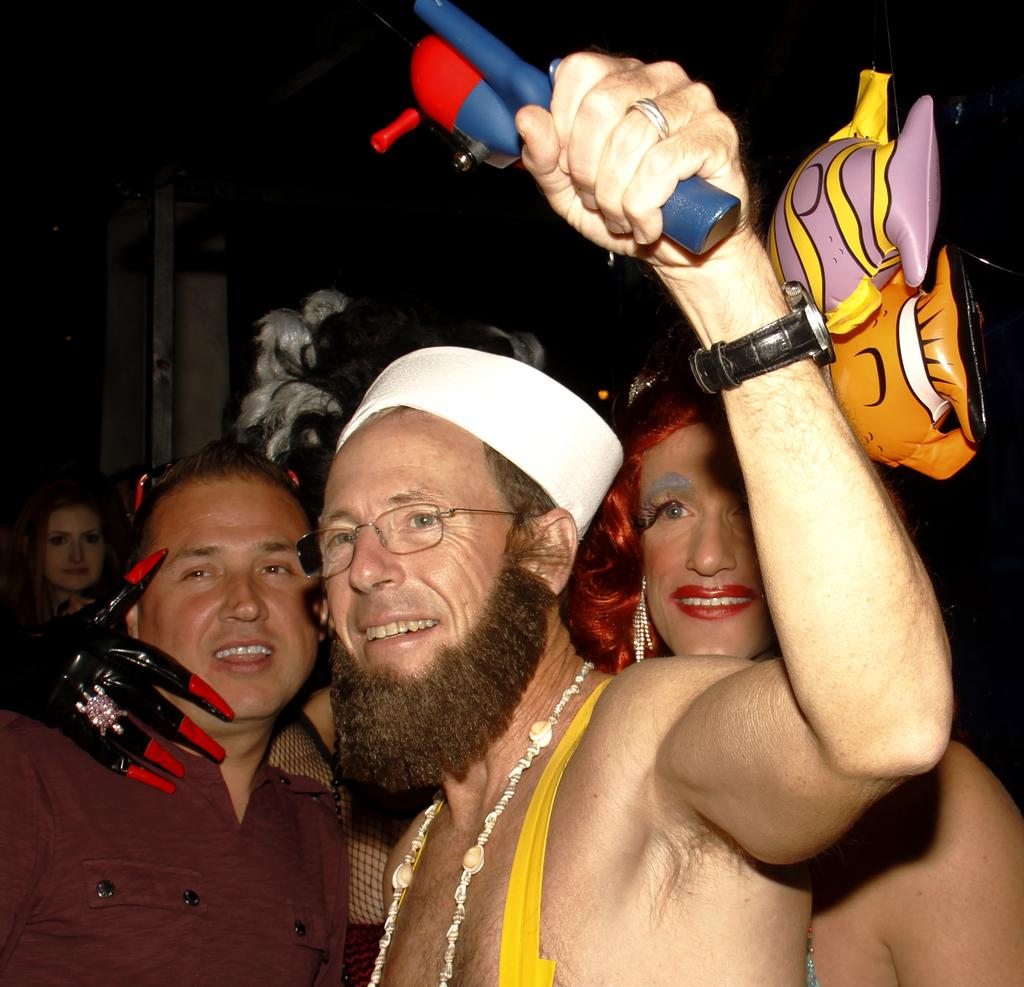What are the people in the image doing? The people in the image are standing in the center. Can you describe the appearance of some of the people? Some of the people are wearing costumes. What else is present in the image besides the people? There is an air balloon in the image. What can be seen in the background of the image? There is a wall in the background of the image. How many eyes can be seen in the jar in the image? There is no jar or eyes present in the image. What type of men are depicted in the image? The provided facts do not mention any specific type of men; the image simply shows people standing in the center. 